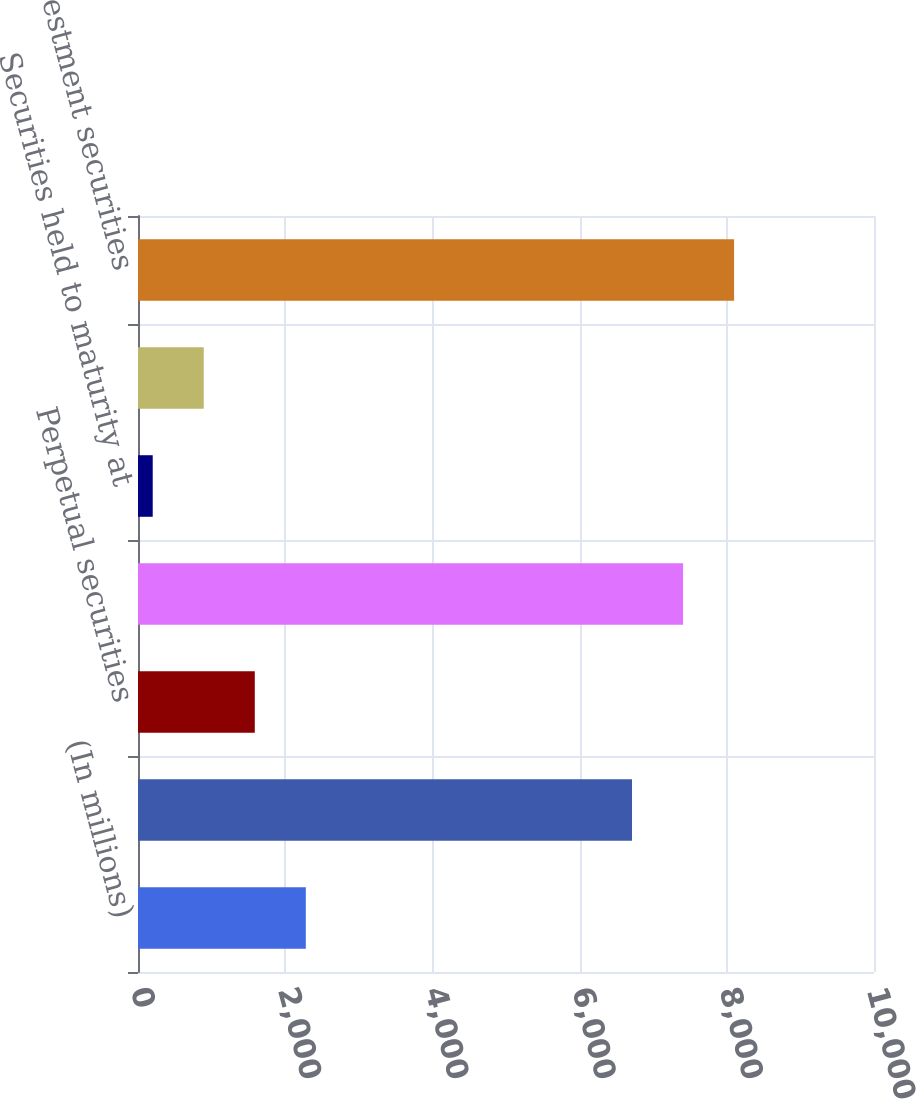<chart> <loc_0><loc_0><loc_500><loc_500><bar_chart><fcel>(In millions)<fcel>Fixed maturities<fcel>Perpetual securities<fcel>Total available for sale<fcel>Securities held to maturity at<fcel>Total held to maturity<fcel>Total investment securities<nl><fcel>2280.2<fcel>6712<fcel>1586.8<fcel>7405.4<fcel>200<fcel>893.4<fcel>8098.8<nl></chart> 